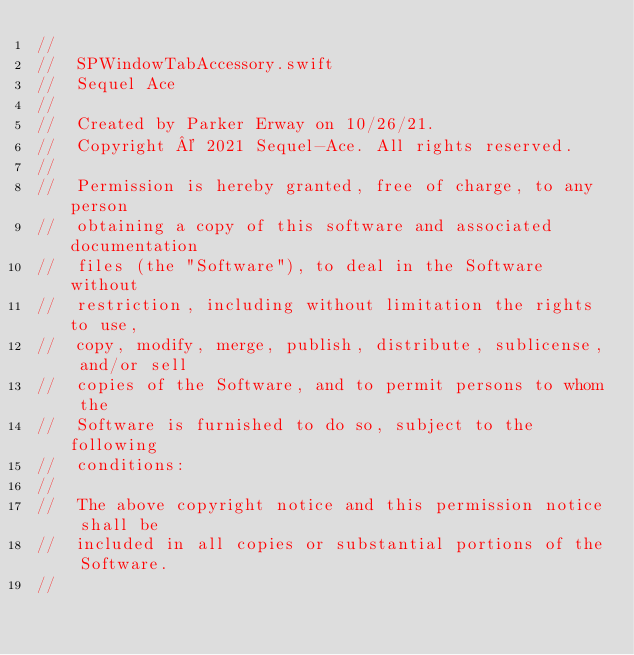<code> <loc_0><loc_0><loc_500><loc_500><_Swift_>//
//  SPWindowTabAccessory.swift
//  Sequel Ace
//
//  Created by Parker Erway on 10/26/21.
//  Copyright © 2021 Sequel-Ace. All rights reserved.
//
//  Permission is hereby granted, free of charge, to any person
//  obtaining a copy of this software and associated documentation
//  files (the "Software"), to deal in the Software without
//  restriction, including without limitation the rights to use,
//  copy, modify, merge, publish, distribute, sublicense, and/or sell
//  copies of the Software, and to permit persons to whom the
//  Software is furnished to do so, subject to the following
//  conditions:
//
//  The above copyright notice and this permission notice shall be
//  included in all copies or substantial portions of the Software.
//</code> 